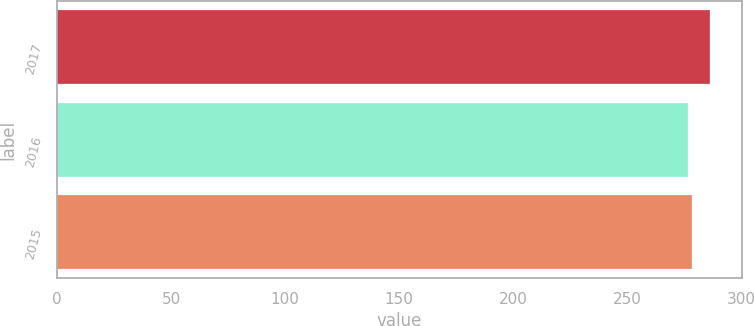Convert chart to OTSL. <chart><loc_0><loc_0><loc_500><loc_500><bar_chart><fcel>2017<fcel>2016<fcel>2015<nl><fcel>286.1<fcel>276.7<fcel>278.4<nl></chart> 